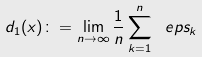Convert formula to latex. <formula><loc_0><loc_0><loc_500><loc_500>d _ { 1 } ( x ) \colon = \lim _ { n \to \infty } \frac { 1 } { n } \sum _ { k = 1 } ^ { n } \ e p s _ { k }</formula> 